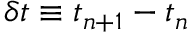Convert formula to latex. <formula><loc_0><loc_0><loc_500><loc_500>\delta t \equiv t _ { n + 1 } - t _ { n }</formula> 